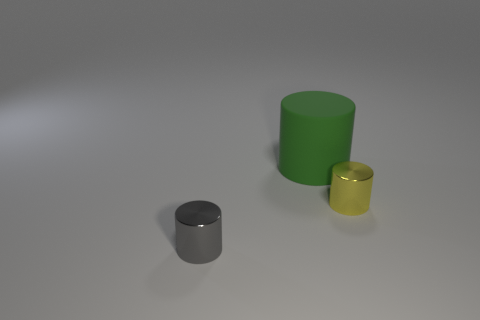What number of rubber things are big green spheres or tiny gray cylinders?
Your answer should be compact. 0. What is the shape of the tiny shiny thing behind the small shiny thing that is left of the tiny yellow cylinder?
Ensure brevity in your answer.  Cylinder. What number of things are small metallic cylinders behind the small gray cylinder or small yellow metal cylinders that are on the right side of the gray metallic cylinder?
Offer a terse response. 1. There is a gray object that is the same material as the small yellow object; what shape is it?
Your answer should be very brief. Cylinder. There is a green thing that is the same shape as the small gray metallic object; what material is it?
Give a very brief answer. Rubber. How many other things are there of the same size as the rubber object?
Make the answer very short. 0. What material is the green cylinder?
Provide a succinct answer. Rubber. Is the number of small metallic cylinders right of the small gray object greater than the number of red cylinders?
Make the answer very short. Yes. Is there a green block?
Ensure brevity in your answer.  No. What number of other things are there of the same shape as the gray metal object?
Your answer should be very brief. 2. 